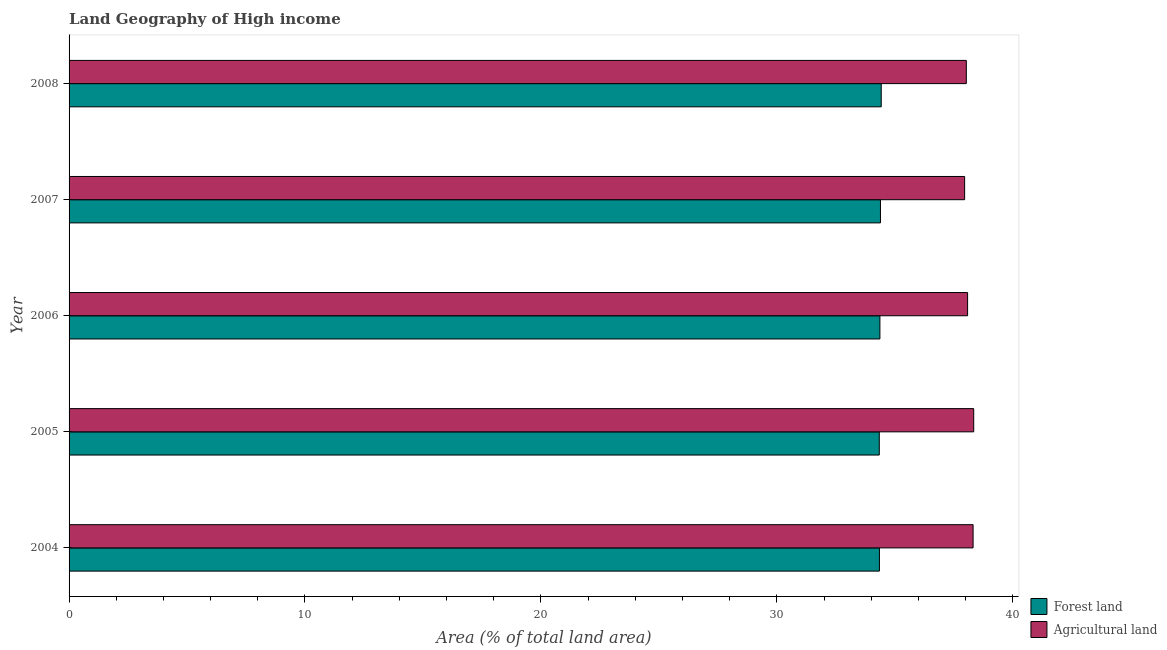Are the number of bars on each tick of the Y-axis equal?
Your answer should be very brief. Yes. What is the label of the 4th group of bars from the top?
Offer a terse response. 2005. In how many cases, is the number of bars for a given year not equal to the number of legend labels?
Your answer should be very brief. 0. What is the percentage of land area under agriculture in 2007?
Offer a terse response. 37.96. Across all years, what is the maximum percentage of land area under forests?
Provide a succinct answer. 34.43. Across all years, what is the minimum percentage of land area under agriculture?
Keep it short and to the point. 37.96. In which year was the percentage of land area under agriculture minimum?
Keep it short and to the point. 2007. What is the total percentage of land area under forests in the graph?
Your answer should be compact. 171.88. What is the difference between the percentage of land area under agriculture in 2005 and that in 2006?
Your answer should be compact. 0.26. What is the difference between the percentage of land area under forests in 2006 and the percentage of land area under agriculture in 2008?
Provide a succinct answer. -3.66. What is the average percentage of land area under agriculture per year?
Your answer should be compact. 38.15. In the year 2007, what is the difference between the percentage of land area under forests and percentage of land area under agriculture?
Make the answer very short. -3.57. What is the ratio of the percentage of land area under forests in 2004 to that in 2008?
Your answer should be very brief. 1. Is the percentage of land area under forests in 2006 less than that in 2008?
Provide a succinct answer. Yes. Is the difference between the percentage of land area under forests in 2004 and 2005 greater than the difference between the percentage of land area under agriculture in 2004 and 2005?
Provide a short and direct response. Yes. What is the difference between the highest and the second highest percentage of land area under forests?
Your answer should be compact. 0.03. What is the difference between the highest and the lowest percentage of land area under forests?
Make the answer very short. 0.08. Is the sum of the percentage of land area under agriculture in 2004 and 2008 greater than the maximum percentage of land area under forests across all years?
Make the answer very short. Yes. What does the 2nd bar from the top in 2006 represents?
Provide a short and direct response. Forest land. What does the 1st bar from the bottom in 2006 represents?
Make the answer very short. Forest land. How many bars are there?
Your response must be concise. 10. Are all the bars in the graph horizontal?
Your answer should be compact. Yes. How many years are there in the graph?
Provide a short and direct response. 5. What is the difference between two consecutive major ticks on the X-axis?
Provide a short and direct response. 10. Are the values on the major ticks of X-axis written in scientific E-notation?
Keep it short and to the point. No. Does the graph contain any zero values?
Your answer should be very brief. No. Does the graph contain grids?
Your answer should be compact. No. How many legend labels are there?
Offer a terse response. 2. What is the title of the graph?
Your response must be concise. Land Geography of High income. Does "Private credit bureau" appear as one of the legend labels in the graph?
Make the answer very short. No. What is the label or title of the X-axis?
Keep it short and to the point. Area (% of total land area). What is the label or title of the Y-axis?
Ensure brevity in your answer.  Year. What is the Area (% of total land area) of Forest land in 2004?
Your response must be concise. 34.35. What is the Area (% of total land area) in Agricultural land in 2004?
Offer a terse response. 38.32. What is the Area (% of total land area) of Forest land in 2005?
Provide a short and direct response. 34.34. What is the Area (% of total land area) of Agricultural land in 2005?
Offer a terse response. 38.34. What is the Area (% of total land area) in Forest land in 2006?
Make the answer very short. 34.37. What is the Area (% of total land area) of Agricultural land in 2006?
Provide a short and direct response. 38.09. What is the Area (% of total land area) in Forest land in 2007?
Make the answer very short. 34.39. What is the Area (% of total land area) in Agricultural land in 2007?
Provide a short and direct response. 37.96. What is the Area (% of total land area) of Forest land in 2008?
Ensure brevity in your answer.  34.43. What is the Area (% of total land area) of Agricultural land in 2008?
Your answer should be very brief. 38.03. Across all years, what is the maximum Area (% of total land area) in Forest land?
Your answer should be compact. 34.43. Across all years, what is the maximum Area (% of total land area) of Agricultural land?
Offer a terse response. 38.34. Across all years, what is the minimum Area (% of total land area) in Forest land?
Offer a terse response. 34.34. Across all years, what is the minimum Area (% of total land area) in Agricultural land?
Your answer should be compact. 37.96. What is the total Area (% of total land area) in Forest land in the graph?
Offer a terse response. 171.88. What is the total Area (% of total land area) of Agricultural land in the graph?
Your response must be concise. 190.74. What is the difference between the Area (% of total land area) of Forest land in 2004 and that in 2005?
Offer a very short reply. 0.01. What is the difference between the Area (% of total land area) in Agricultural land in 2004 and that in 2005?
Ensure brevity in your answer.  -0.03. What is the difference between the Area (% of total land area) in Forest land in 2004 and that in 2006?
Provide a succinct answer. -0.02. What is the difference between the Area (% of total land area) in Agricultural land in 2004 and that in 2006?
Make the answer very short. 0.23. What is the difference between the Area (% of total land area) of Forest land in 2004 and that in 2007?
Your answer should be compact. -0.04. What is the difference between the Area (% of total land area) of Agricultural land in 2004 and that in 2007?
Your response must be concise. 0.36. What is the difference between the Area (% of total land area) in Forest land in 2004 and that in 2008?
Offer a very short reply. -0.08. What is the difference between the Area (% of total land area) of Agricultural land in 2004 and that in 2008?
Give a very brief answer. 0.29. What is the difference between the Area (% of total land area) of Forest land in 2005 and that in 2006?
Your answer should be very brief. -0.03. What is the difference between the Area (% of total land area) in Agricultural land in 2005 and that in 2006?
Keep it short and to the point. 0.26. What is the difference between the Area (% of total land area) of Forest land in 2005 and that in 2007?
Your answer should be very brief. -0.05. What is the difference between the Area (% of total land area) of Agricultural land in 2005 and that in 2007?
Your response must be concise. 0.38. What is the difference between the Area (% of total land area) of Forest land in 2005 and that in 2008?
Your response must be concise. -0.08. What is the difference between the Area (% of total land area) of Agricultural land in 2005 and that in 2008?
Provide a succinct answer. 0.31. What is the difference between the Area (% of total land area) of Forest land in 2006 and that in 2007?
Offer a very short reply. -0.02. What is the difference between the Area (% of total land area) of Agricultural land in 2006 and that in 2007?
Your response must be concise. 0.13. What is the difference between the Area (% of total land area) in Forest land in 2006 and that in 2008?
Make the answer very short. -0.06. What is the difference between the Area (% of total land area) in Agricultural land in 2006 and that in 2008?
Make the answer very short. 0.05. What is the difference between the Area (% of total land area) in Forest land in 2007 and that in 2008?
Ensure brevity in your answer.  -0.03. What is the difference between the Area (% of total land area) in Agricultural land in 2007 and that in 2008?
Give a very brief answer. -0.07. What is the difference between the Area (% of total land area) in Forest land in 2004 and the Area (% of total land area) in Agricultural land in 2005?
Your answer should be very brief. -4. What is the difference between the Area (% of total land area) of Forest land in 2004 and the Area (% of total land area) of Agricultural land in 2006?
Provide a short and direct response. -3.74. What is the difference between the Area (% of total land area) of Forest land in 2004 and the Area (% of total land area) of Agricultural land in 2007?
Make the answer very short. -3.61. What is the difference between the Area (% of total land area) of Forest land in 2004 and the Area (% of total land area) of Agricultural land in 2008?
Your answer should be very brief. -3.68. What is the difference between the Area (% of total land area) of Forest land in 2005 and the Area (% of total land area) of Agricultural land in 2006?
Provide a succinct answer. -3.74. What is the difference between the Area (% of total land area) of Forest land in 2005 and the Area (% of total land area) of Agricultural land in 2007?
Your response must be concise. -3.62. What is the difference between the Area (% of total land area) of Forest land in 2005 and the Area (% of total land area) of Agricultural land in 2008?
Give a very brief answer. -3.69. What is the difference between the Area (% of total land area) in Forest land in 2006 and the Area (% of total land area) in Agricultural land in 2007?
Offer a very short reply. -3.59. What is the difference between the Area (% of total land area) of Forest land in 2006 and the Area (% of total land area) of Agricultural land in 2008?
Your response must be concise. -3.66. What is the difference between the Area (% of total land area) in Forest land in 2007 and the Area (% of total land area) in Agricultural land in 2008?
Keep it short and to the point. -3.64. What is the average Area (% of total land area) in Forest land per year?
Make the answer very short. 34.38. What is the average Area (% of total land area) in Agricultural land per year?
Offer a very short reply. 38.15. In the year 2004, what is the difference between the Area (% of total land area) of Forest land and Area (% of total land area) of Agricultural land?
Give a very brief answer. -3.97. In the year 2005, what is the difference between the Area (% of total land area) in Forest land and Area (% of total land area) in Agricultural land?
Offer a terse response. -4. In the year 2006, what is the difference between the Area (% of total land area) in Forest land and Area (% of total land area) in Agricultural land?
Provide a short and direct response. -3.72. In the year 2007, what is the difference between the Area (% of total land area) in Forest land and Area (% of total land area) in Agricultural land?
Provide a succinct answer. -3.57. In the year 2008, what is the difference between the Area (% of total land area) in Forest land and Area (% of total land area) in Agricultural land?
Offer a very short reply. -3.61. What is the ratio of the Area (% of total land area) of Agricultural land in 2004 to that in 2005?
Make the answer very short. 1. What is the ratio of the Area (% of total land area) of Forest land in 2004 to that in 2006?
Your response must be concise. 1. What is the ratio of the Area (% of total land area) of Agricultural land in 2004 to that in 2007?
Offer a terse response. 1.01. What is the ratio of the Area (% of total land area) of Forest land in 2004 to that in 2008?
Your answer should be compact. 1. What is the ratio of the Area (% of total land area) in Agricultural land in 2004 to that in 2008?
Your answer should be compact. 1.01. What is the ratio of the Area (% of total land area) of Agricultural land in 2005 to that in 2006?
Provide a succinct answer. 1.01. What is the ratio of the Area (% of total land area) in Agricultural land in 2005 to that in 2007?
Your answer should be compact. 1.01. What is the ratio of the Area (% of total land area) of Forest land in 2005 to that in 2008?
Provide a short and direct response. 1. What is the ratio of the Area (% of total land area) in Agricultural land in 2005 to that in 2008?
Provide a short and direct response. 1.01. What is the ratio of the Area (% of total land area) of Forest land in 2006 to that in 2007?
Offer a very short reply. 1. What is the ratio of the Area (% of total land area) in Agricultural land in 2006 to that in 2007?
Keep it short and to the point. 1. What is the ratio of the Area (% of total land area) in Forest land in 2006 to that in 2008?
Ensure brevity in your answer.  1. What is the ratio of the Area (% of total land area) of Forest land in 2007 to that in 2008?
Offer a terse response. 1. What is the difference between the highest and the second highest Area (% of total land area) in Forest land?
Give a very brief answer. 0.03. What is the difference between the highest and the second highest Area (% of total land area) in Agricultural land?
Provide a succinct answer. 0.03. What is the difference between the highest and the lowest Area (% of total land area) of Forest land?
Offer a very short reply. 0.08. What is the difference between the highest and the lowest Area (% of total land area) in Agricultural land?
Your response must be concise. 0.38. 